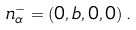<formula> <loc_0><loc_0><loc_500><loc_500>n _ { \alpha } ^ { - } = ( 0 , b , 0 , 0 ) \, .</formula> 